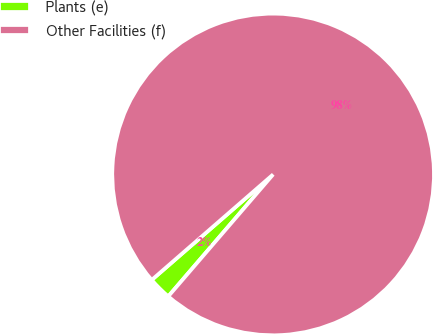Convert chart. <chart><loc_0><loc_0><loc_500><loc_500><pie_chart><fcel>Plants (e)<fcel>Other Facilities (f)<nl><fcel>2.31%<fcel>97.69%<nl></chart> 